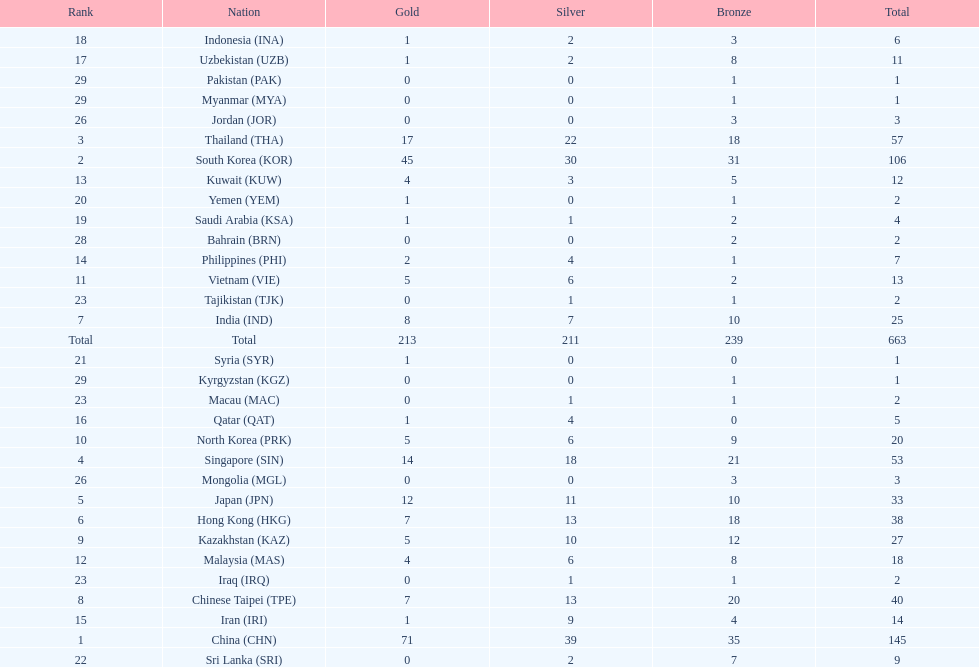Could you parse the entire table as a dict? {'header': ['Rank', 'Nation', 'Gold', 'Silver', 'Bronze', 'Total'], 'rows': [['18', 'Indonesia\xa0(INA)', '1', '2', '3', '6'], ['17', 'Uzbekistan\xa0(UZB)', '1', '2', '8', '11'], ['29', 'Pakistan\xa0(PAK)', '0', '0', '1', '1'], ['29', 'Myanmar\xa0(MYA)', '0', '0', '1', '1'], ['26', 'Jordan\xa0(JOR)', '0', '0', '3', '3'], ['3', 'Thailand\xa0(THA)', '17', '22', '18', '57'], ['2', 'South Korea\xa0(KOR)', '45', '30', '31', '106'], ['13', 'Kuwait\xa0(KUW)', '4', '3', '5', '12'], ['20', 'Yemen\xa0(YEM)', '1', '0', '1', '2'], ['19', 'Saudi Arabia\xa0(KSA)', '1', '1', '2', '4'], ['28', 'Bahrain\xa0(BRN)', '0', '0', '2', '2'], ['14', 'Philippines\xa0(PHI)', '2', '4', '1', '7'], ['11', 'Vietnam\xa0(VIE)', '5', '6', '2', '13'], ['23', 'Tajikistan\xa0(TJK)', '0', '1', '1', '2'], ['7', 'India\xa0(IND)', '8', '7', '10', '25'], ['Total', 'Total', '213', '211', '239', '663'], ['21', 'Syria\xa0(SYR)', '1', '0', '0', '1'], ['29', 'Kyrgyzstan\xa0(KGZ)', '0', '0', '1', '1'], ['23', 'Macau\xa0(MAC)', '0', '1', '1', '2'], ['16', 'Qatar\xa0(QAT)', '1', '4', '0', '5'], ['10', 'North Korea\xa0(PRK)', '5', '6', '9', '20'], ['4', 'Singapore\xa0(SIN)', '14', '18', '21', '53'], ['26', 'Mongolia\xa0(MGL)', '0', '0', '3', '3'], ['5', 'Japan\xa0(JPN)', '12', '11', '10', '33'], ['6', 'Hong Kong\xa0(HKG)', '7', '13', '18', '38'], ['9', 'Kazakhstan\xa0(KAZ)', '5', '10', '12', '27'], ['12', 'Malaysia\xa0(MAS)', '4', '6', '8', '18'], ['23', 'Iraq\xa0(IRQ)', '0', '1', '1', '2'], ['8', 'Chinese Taipei\xa0(TPE)', '7', '13', '20', '40'], ['15', 'Iran\xa0(IRI)', '1', '9', '4', '14'], ['1', 'China\xa0(CHN)', '71', '39', '35', '145'], ['22', 'Sri Lanka\xa0(SRI)', '0', '2', '7', '9']]} Which nations possess an equal quantity of silver medals in the asian youth games as north korea? Vietnam (VIE), Malaysia (MAS). 